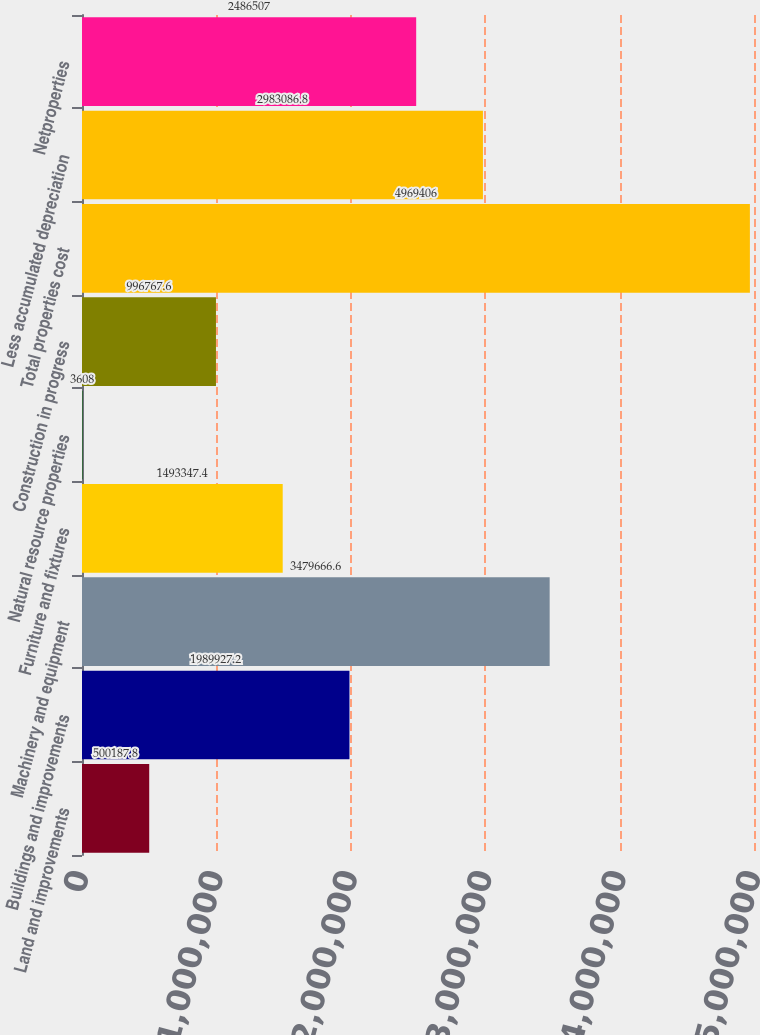Convert chart. <chart><loc_0><loc_0><loc_500><loc_500><bar_chart><fcel>Land and improvements<fcel>Buildings and improvements<fcel>Machinery and equipment<fcel>Furniture and fixtures<fcel>Natural resource properties<fcel>Construction in progress<fcel>Total properties cost<fcel>Less accumulated depreciation<fcel>Netproperties<nl><fcel>500188<fcel>1.98993e+06<fcel>3.47967e+06<fcel>1.49335e+06<fcel>3608<fcel>996768<fcel>4.96941e+06<fcel>2.98309e+06<fcel>2.48651e+06<nl></chart> 